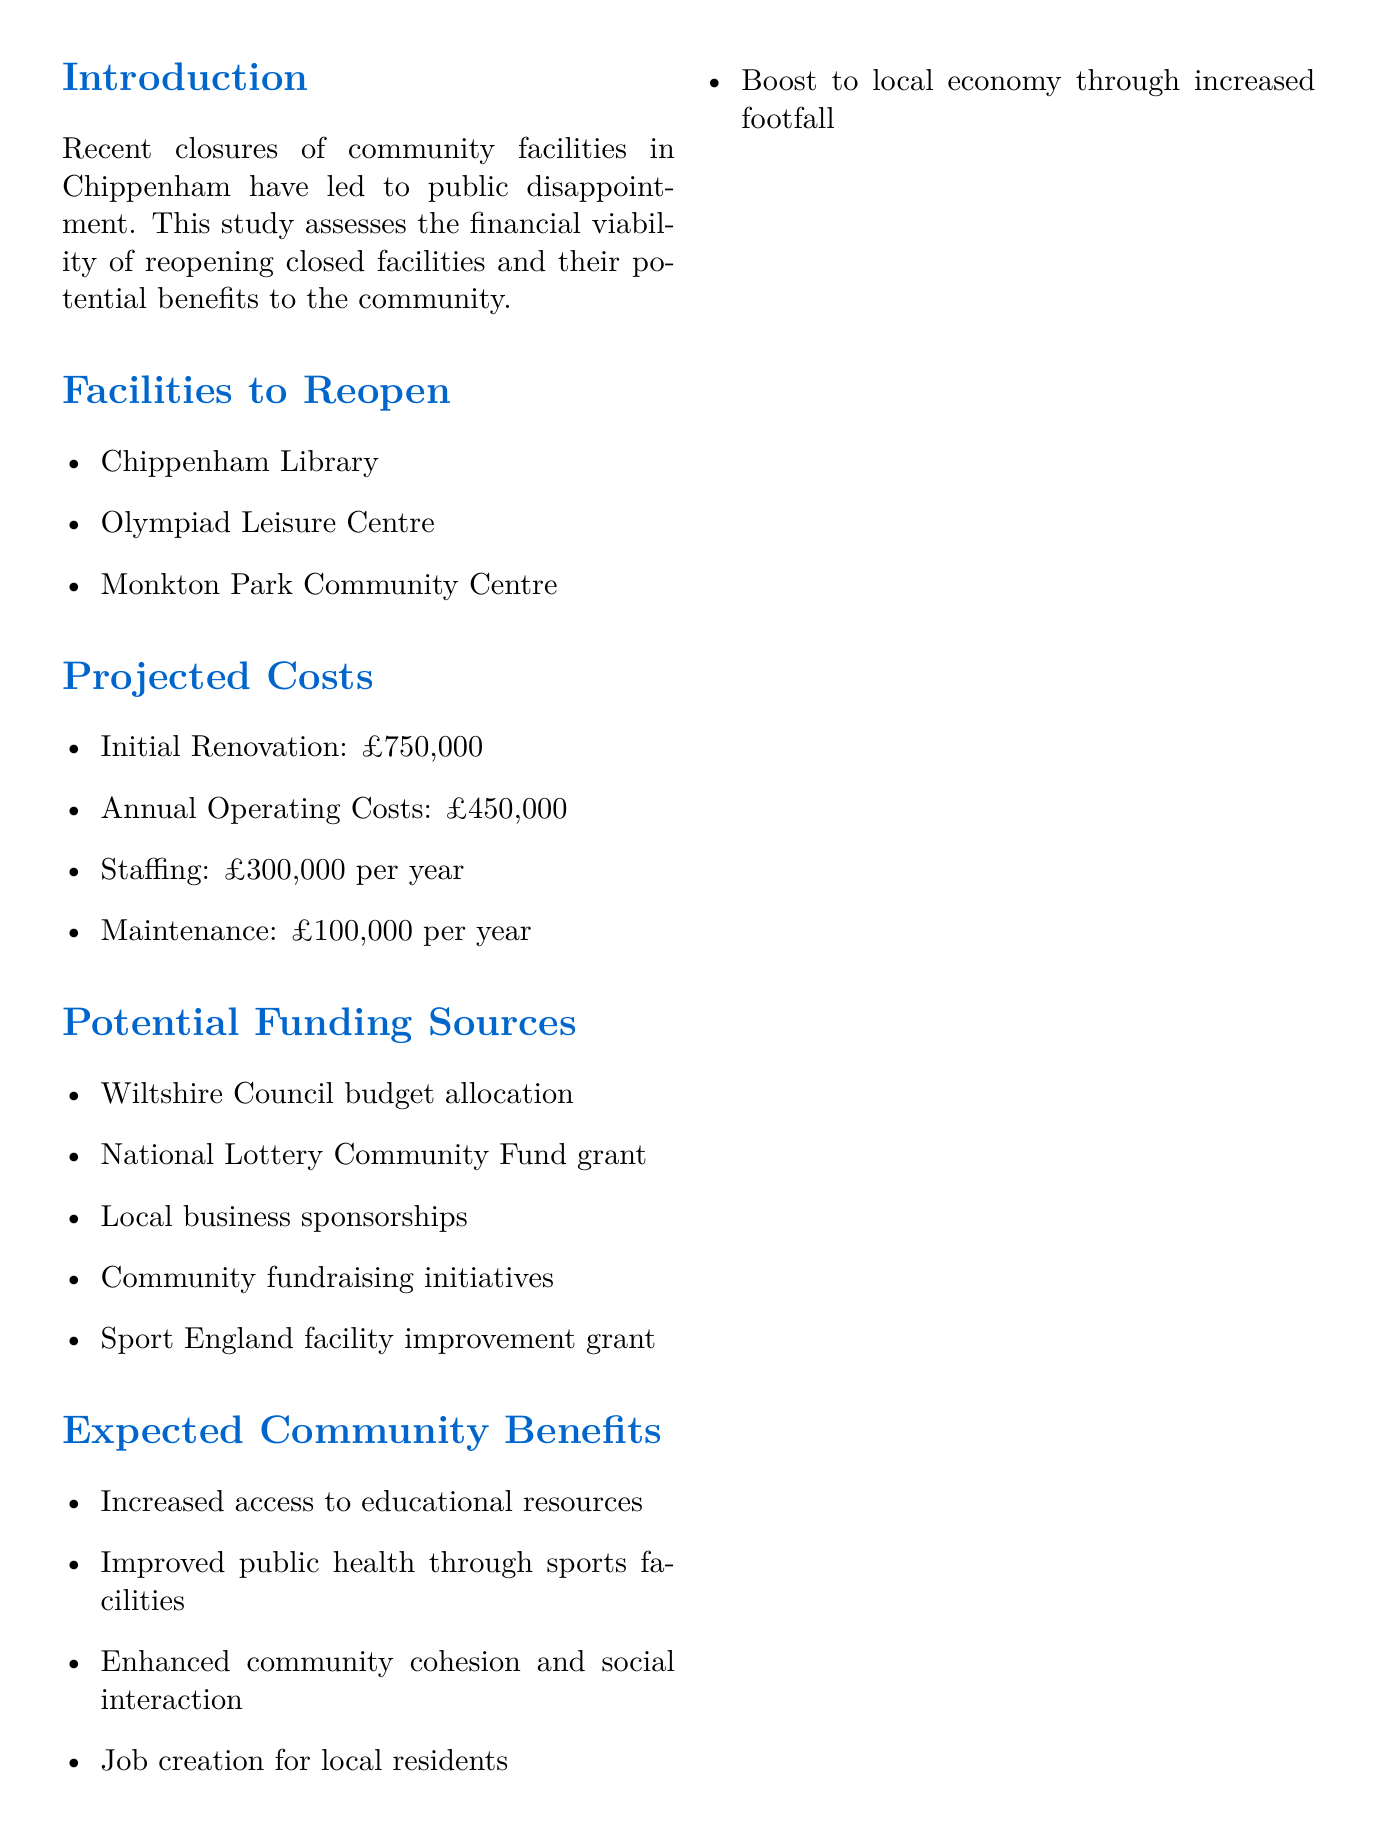what are the facilities to be reopened? The document lists three specific facilities to be reopened in Chippenham: Chippenham Library, Olympiad Leisure Centre, and Monkton Park Community Centre.
Answer: Chippenham Library, Olympiad Leisure Centre, Monkton Park Community Centre what is the initial renovation cost? The initial renovation cost is provided in the projected costs section of the document.
Answer: £750,000 which year is the break-even point projected for? The document indicates that the financial projections show the break-even point will be reached after three years of operation.
Answer: Year 3 what is the total annual operating cost? The total annual operating cost is mentioned in the projected costs and includes staffing and maintenance as well.
Answer: £450,000 what is one expected community benefit of reopening facilities? The document outlines several expected community benefits, including increased access to educational resources and improved public health.
Answer: Increased access to educational resources list one potential funding source. The document provides a list of potential funding sources for reopening the facilities and one of them is the National Lottery Community Fund grant.
Answer: National Lottery Community Fund grant what is the projected revenue for year 1? The projected revenue for year 1 is specifically mentioned in the financial projections section.
Answer: £350,000 what is the recommended approach for reopening facilities? The conclusion section provides a recommendation regarding the approach to reopening the facilities in a phased manner.
Answer: Phased reopening, starting with Olympiad Leisure Centre 